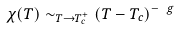<formula> <loc_0><loc_0><loc_500><loc_500>\chi ( T ) \sim _ { T \to T _ { c } ^ { + } } ( T - T _ { c } ) ^ { - \ g }</formula> 